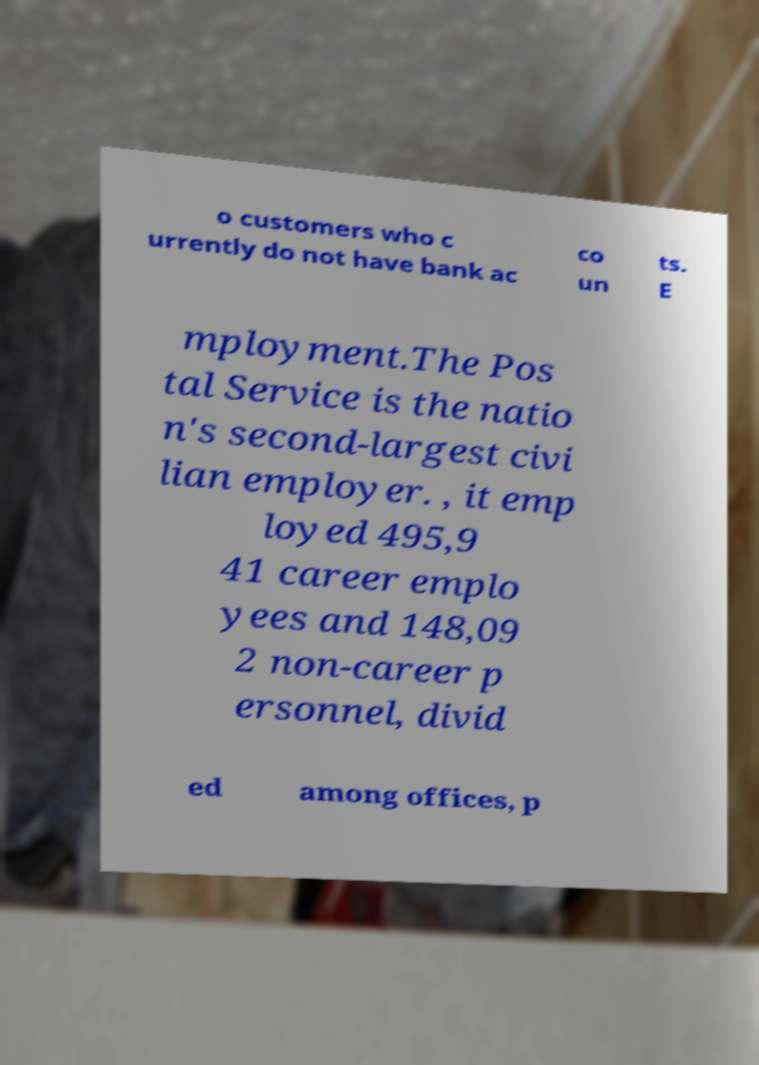Please identify and transcribe the text found in this image. o customers who c urrently do not have bank ac co un ts. E mployment.The Pos tal Service is the natio n's second-largest civi lian employer. , it emp loyed 495,9 41 career emplo yees and 148,09 2 non-career p ersonnel, divid ed among offices, p 